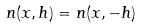<formula> <loc_0><loc_0><loc_500><loc_500>n ( x , h ) = n ( x , - h )</formula> 